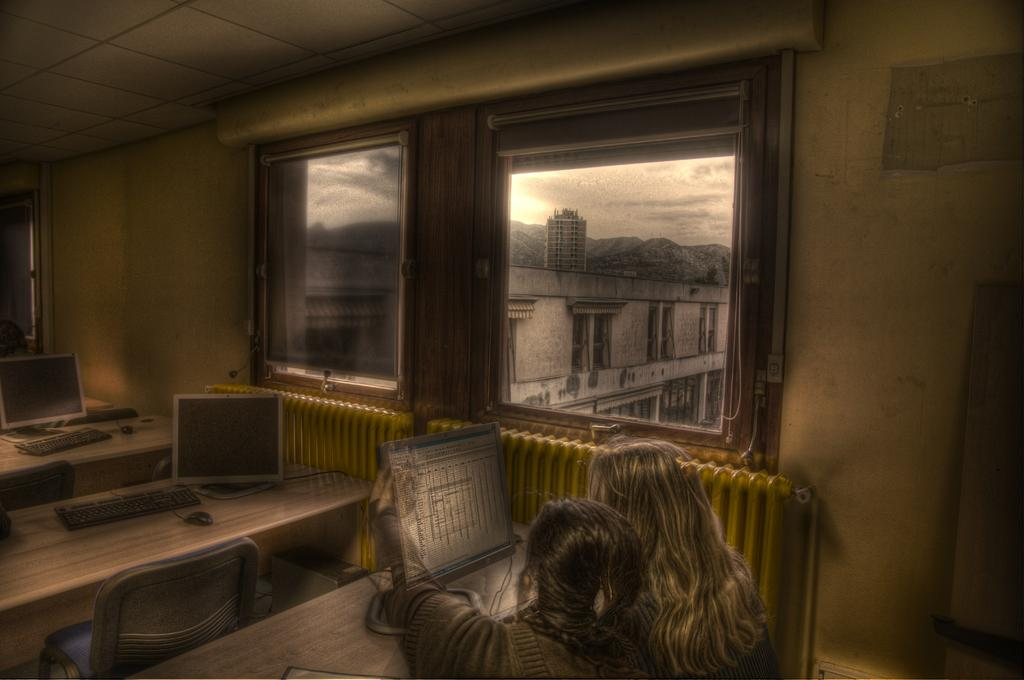Who is present in the image? There are women in the image. What objects can be seen in the image? There are personal computers, a table, and chairs in the image. What type of structure is visible in the image? There are buildings in the image. What can be seen in the sky in the image? There are clouds visible in the sky. What type of furniture is floating in the stream in the image? There is no stream or furniture present in the image. 